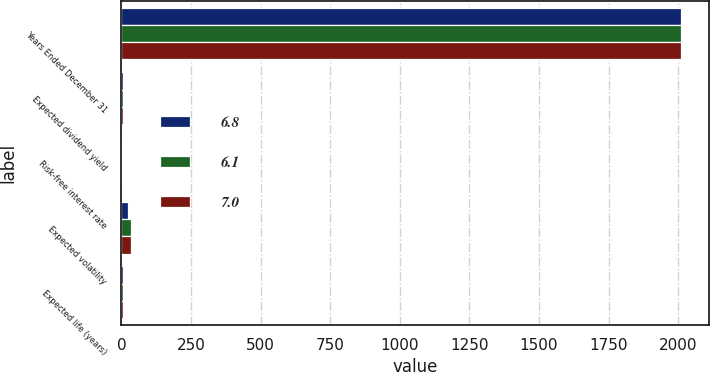Convert chart to OTSL. <chart><loc_0><loc_0><loc_500><loc_500><stacked_bar_chart><ecel><fcel>Years Ended December 31<fcel>Expected dividend yield<fcel>Risk-free interest rate<fcel>Expected volatility<fcel>Expected life (years)<nl><fcel>6.8<fcel>2011<fcel>4.3<fcel>2.5<fcel>23.4<fcel>7<nl><fcel>6.1<fcel>2010<fcel>4.1<fcel>2.8<fcel>33.7<fcel>6.8<nl><fcel>7<fcel>2009<fcel>6.3<fcel>2.2<fcel>33.8<fcel>6.1<nl></chart> 